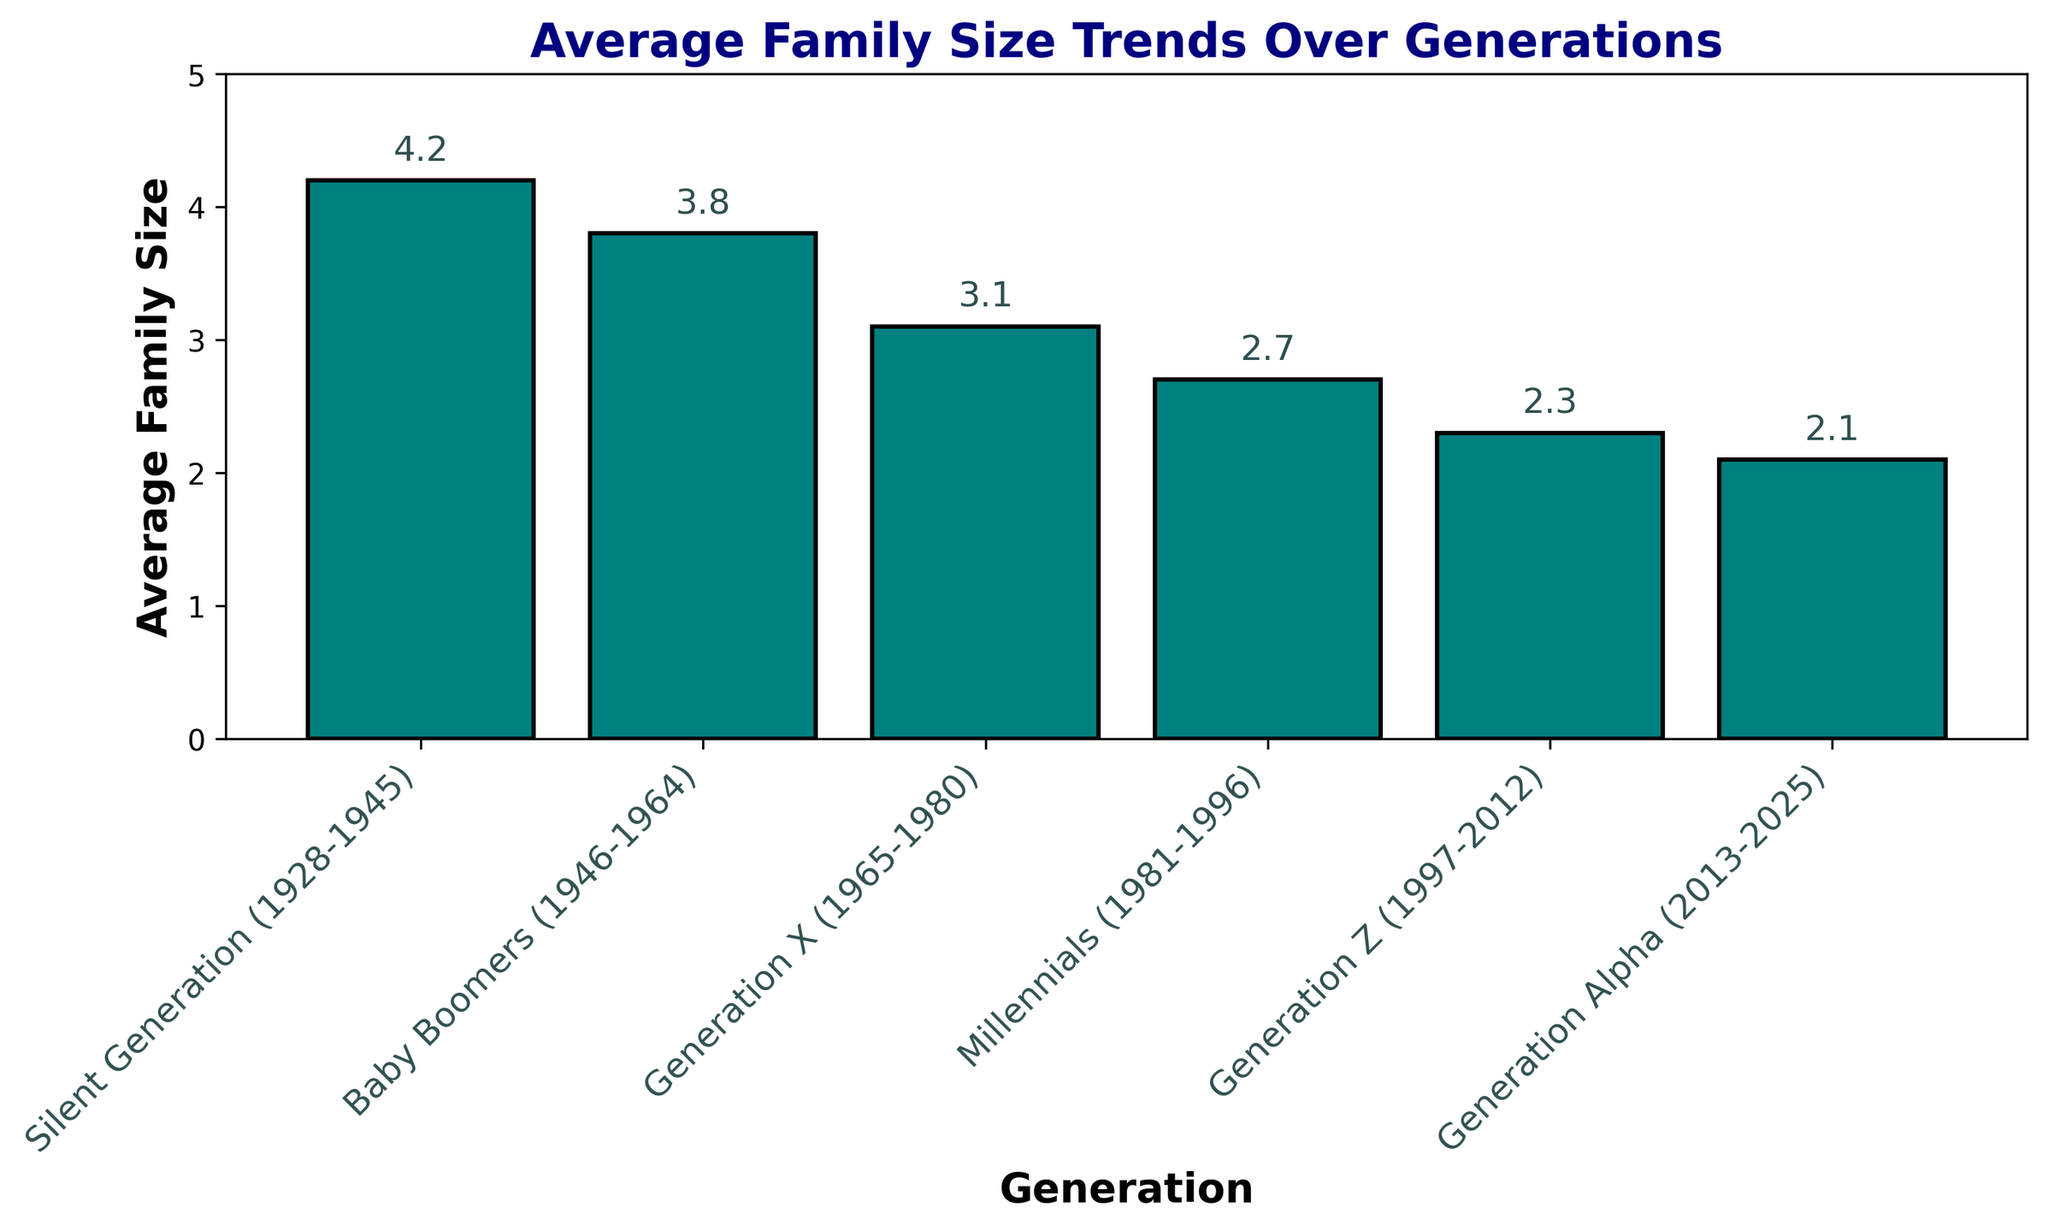Which generation has the largest average family size? The bar representing the Silent Generation (1928-1945) is the tallest among all the bars in the chart, indicating the largest average family size.
Answer: Silent Generation (1928-1945) What is the difference in average family size between Millennials and Baby Boomers? The average family size for Millennials is 2.7 and for Baby Boomers is 3.8. Subtracting the two values gives 3.8 - 2.7 = 1.1.
Answer: 1.1 Compare the average family size between Generation X and Generation Alpha. Which one is higher and by how much? Generation X has an average family size of 3.1, while Generation Alpha has 2.1. Subtracting the two values gives 3.1 - 2.1 = 1.0, indicating that Generation X is higher by 1.0.
Answer: Generation X, by 1.0 What trend can be observed in the average family size from the Silent Generation to Generation Alpha? By looking at the heights of the bars from left to right, it is apparent that each successive generation has a shorter bar, indicating a decreasing trend in average family size over time.
Answer: Decreasing trend Which two consecutive generations have the smallest decrease in average family size? The smallest decrease can be observed by comparing the difference between consecutive generation values. The smallest difference is between Generation Z (2.3) and Generation Alpha (2.1), which is 2.3 - 2.1 = 0.2.
Answer: Generation Z and Generation Alpha What is the total average family size of all generations combined? Summing up the average family sizes for each generation: 
4.2 (Silent Generation) + 3.8 (Baby Boomers) + 3.1 (Generation X) + 2.7 (Millennials) + 2.3 (Generation Z) + 2.1 (Generation Alpha) = 18.2.
Answer: 18.2 What is the average family size in the middle generation (Generation X)? Referring to the bar labeled Generation X (1965-1980), the height shows an average family size of 3.1.
Answer: 3.1 